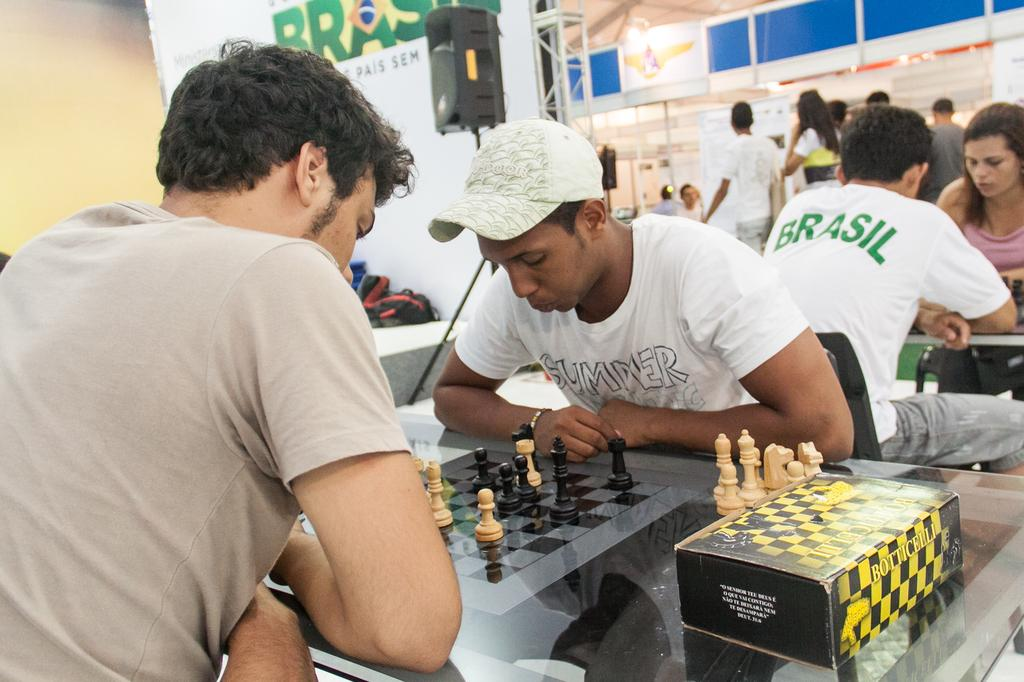Provide a one-sentence caption for the provided image. Two men are playing a game of chess in Brazil. 